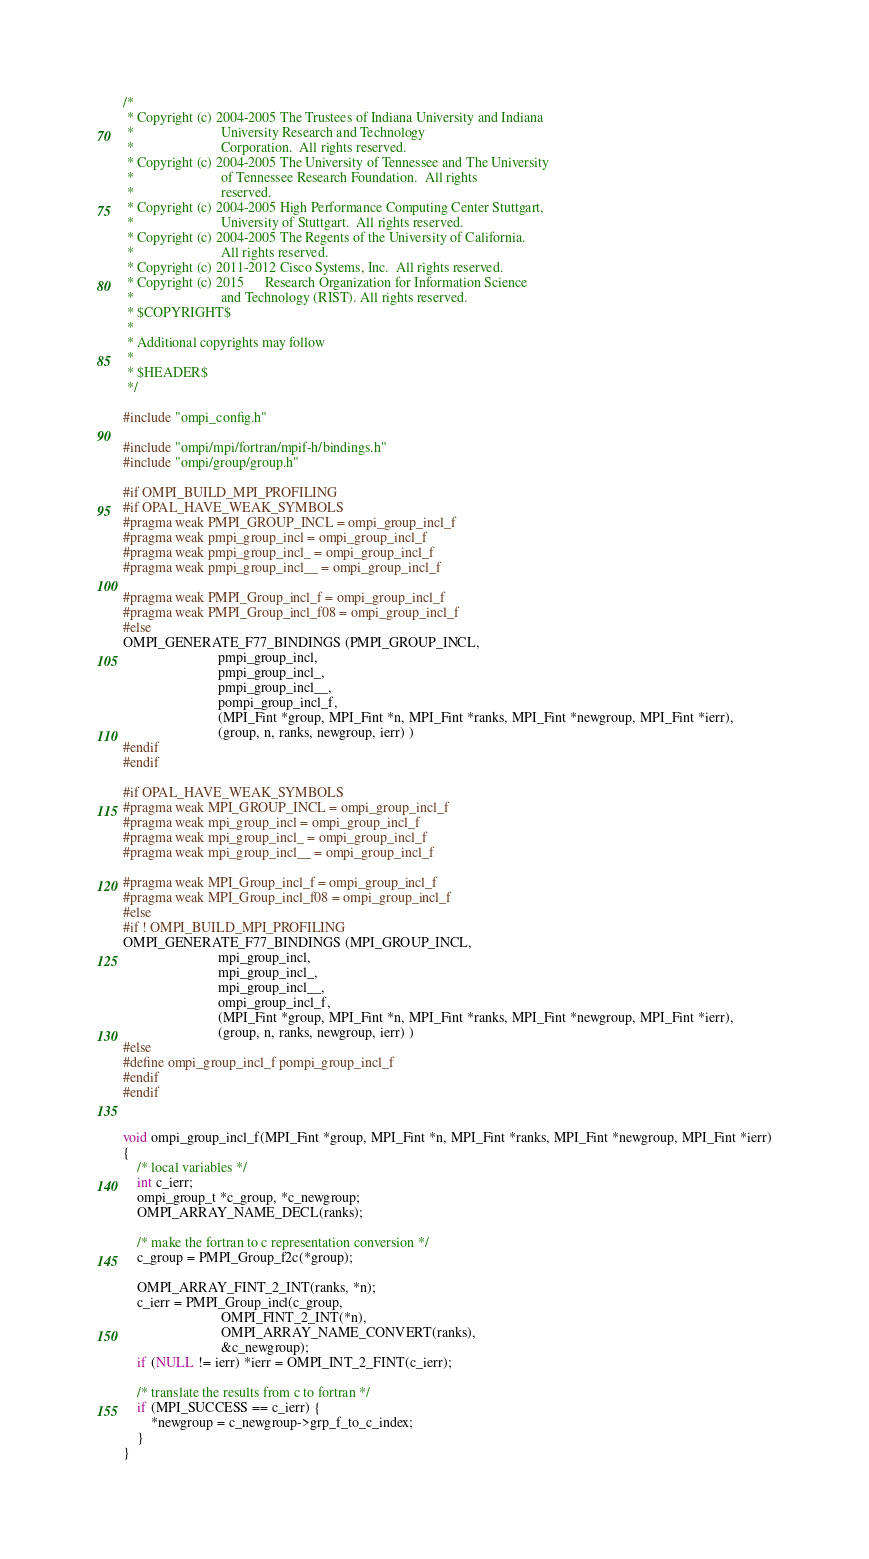Convert code to text. <code><loc_0><loc_0><loc_500><loc_500><_C_>/*
 * Copyright (c) 2004-2005 The Trustees of Indiana University and Indiana
 *                         University Research and Technology
 *                         Corporation.  All rights reserved.
 * Copyright (c) 2004-2005 The University of Tennessee and The University
 *                         of Tennessee Research Foundation.  All rights
 *                         reserved.
 * Copyright (c) 2004-2005 High Performance Computing Center Stuttgart,
 *                         University of Stuttgart.  All rights reserved.
 * Copyright (c) 2004-2005 The Regents of the University of California.
 *                         All rights reserved.
 * Copyright (c) 2011-2012 Cisco Systems, Inc.  All rights reserved.
 * Copyright (c) 2015      Research Organization for Information Science
 *                         and Technology (RIST). All rights reserved.
 * $COPYRIGHT$
 *
 * Additional copyrights may follow
 *
 * $HEADER$
 */

#include "ompi_config.h"

#include "ompi/mpi/fortran/mpif-h/bindings.h"
#include "ompi/group/group.h"

#if OMPI_BUILD_MPI_PROFILING
#if OPAL_HAVE_WEAK_SYMBOLS
#pragma weak PMPI_GROUP_INCL = ompi_group_incl_f
#pragma weak pmpi_group_incl = ompi_group_incl_f
#pragma weak pmpi_group_incl_ = ompi_group_incl_f
#pragma weak pmpi_group_incl__ = ompi_group_incl_f

#pragma weak PMPI_Group_incl_f = ompi_group_incl_f
#pragma weak PMPI_Group_incl_f08 = ompi_group_incl_f
#else
OMPI_GENERATE_F77_BINDINGS (PMPI_GROUP_INCL,
                           pmpi_group_incl,
                           pmpi_group_incl_,
                           pmpi_group_incl__,
                           pompi_group_incl_f,
                           (MPI_Fint *group, MPI_Fint *n, MPI_Fint *ranks, MPI_Fint *newgroup, MPI_Fint *ierr),
                           (group, n, ranks, newgroup, ierr) )
#endif
#endif

#if OPAL_HAVE_WEAK_SYMBOLS
#pragma weak MPI_GROUP_INCL = ompi_group_incl_f
#pragma weak mpi_group_incl = ompi_group_incl_f
#pragma weak mpi_group_incl_ = ompi_group_incl_f
#pragma weak mpi_group_incl__ = ompi_group_incl_f

#pragma weak MPI_Group_incl_f = ompi_group_incl_f
#pragma weak MPI_Group_incl_f08 = ompi_group_incl_f
#else
#if ! OMPI_BUILD_MPI_PROFILING
OMPI_GENERATE_F77_BINDINGS (MPI_GROUP_INCL,
                           mpi_group_incl,
                           mpi_group_incl_,
                           mpi_group_incl__,
                           ompi_group_incl_f,
                           (MPI_Fint *group, MPI_Fint *n, MPI_Fint *ranks, MPI_Fint *newgroup, MPI_Fint *ierr),
                           (group, n, ranks, newgroup, ierr) )
#else
#define ompi_group_incl_f pompi_group_incl_f
#endif
#endif


void ompi_group_incl_f(MPI_Fint *group, MPI_Fint *n, MPI_Fint *ranks, MPI_Fint *newgroup, MPI_Fint *ierr)
{
    /* local variables */
    int c_ierr;
    ompi_group_t *c_group, *c_newgroup;
    OMPI_ARRAY_NAME_DECL(ranks);

    /* make the fortran to c representation conversion */
    c_group = PMPI_Group_f2c(*group);

    OMPI_ARRAY_FINT_2_INT(ranks, *n);
    c_ierr = PMPI_Group_incl(c_group,
                            OMPI_FINT_2_INT(*n),
                            OMPI_ARRAY_NAME_CONVERT(ranks),
                            &c_newgroup);
    if (NULL != ierr) *ierr = OMPI_INT_2_FINT(c_ierr);

    /* translate the results from c to fortran */
    if (MPI_SUCCESS == c_ierr) {
        *newgroup = c_newgroup->grp_f_to_c_index;
    }
}
</code> 